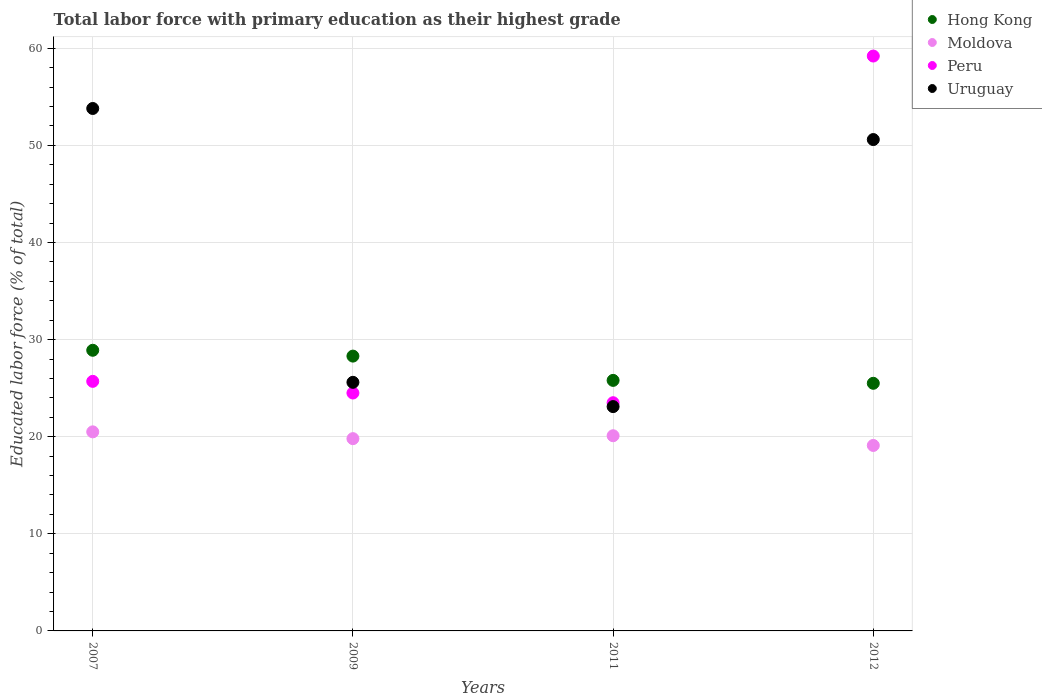How many different coloured dotlines are there?
Your answer should be compact. 4. Across all years, what is the minimum percentage of total labor force with primary education in Peru?
Provide a succinct answer. 23.5. In which year was the percentage of total labor force with primary education in Uruguay maximum?
Your response must be concise. 2007. In which year was the percentage of total labor force with primary education in Uruguay minimum?
Ensure brevity in your answer.  2011. What is the total percentage of total labor force with primary education in Peru in the graph?
Keep it short and to the point. 132.9. What is the difference between the percentage of total labor force with primary education in Uruguay in 2007 and that in 2012?
Give a very brief answer. 3.2. What is the difference between the percentage of total labor force with primary education in Moldova in 2009 and the percentage of total labor force with primary education in Hong Kong in 2007?
Ensure brevity in your answer.  -9.1. What is the average percentage of total labor force with primary education in Hong Kong per year?
Your answer should be very brief. 27.12. In the year 2011, what is the difference between the percentage of total labor force with primary education in Uruguay and percentage of total labor force with primary education in Hong Kong?
Make the answer very short. -2.7. What is the ratio of the percentage of total labor force with primary education in Uruguay in 2007 to that in 2012?
Your response must be concise. 1.06. Is the percentage of total labor force with primary education in Hong Kong in 2007 less than that in 2009?
Offer a very short reply. No. Is the difference between the percentage of total labor force with primary education in Uruguay in 2007 and 2011 greater than the difference between the percentage of total labor force with primary education in Hong Kong in 2007 and 2011?
Your response must be concise. Yes. What is the difference between the highest and the second highest percentage of total labor force with primary education in Hong Kong?
Provide a succinct answer. 0.6. What is the difference between the highest and the lowest percentage of total labor force with primary education in Uruguay?
Provide a short and direct response. 30.7. In how many years, is the percentage of total labor force with primary education in Peru greater than the average percentage of total labor force with primary education in Peru taken over all years?
Ensure brevity in your answer.  1. Is it the case that in every year, the sum of the percentage of total labor force with primary education in Peru and percentage of total labor force with primary education in Moldova  is greater than the sum of percentage of total labor force with primary education in Hong Kong and percentage of total labor force with primary education in Uruguay?
Offer a terse response. No. Is it the case that in every year, the sum of the percentage of total labor force with primary education in Uruguay and percentage of total labor force with primary education in Moldova  is greater than the percentage of total labor force with primary education in Peru?
Your response must be concise. Yes. Does the percentage of total labor force with primary education in Moldova monotonically increase over the years?
Give a very brief answer. No. Is the percentage of total labor force with primary education in Hong Kong strictly less than the percentage of total labor force with primary education in Moldova over the years?
Your answer should be compact. No. How many years are there in the graph?
Offer a very short reply. 4. Does the graph contain grids?
Your answer should be compact. Yes. How many legend labels are there?
Give a very brief answer. 4. How are the legend labels stacked?
Your answer should be compact. Vertical. What is the title of the graph?
Your response must be concise. Total labor force with primary education as their highest grade. Does "Solomon Islands" appear as one of the legend labels in the graph?
Provide a short and direct response. No. What is the label or title of the X-axis?
Give a very brief answer. Years. What is the label or title of the Y-axis?
Offer a terse response. Educated labor force (% of total). What is the Educated labor force (% of total) of Hong Kong in 2007?
Your response must be concise. 28.9. What is the Educated labor force (% of total) in Moldova in 2007?
Offer a very short reply. 20.5. What is the Educated labor force (% of total) in Peru in 2007?
Offer a very short reply. 25.7. What is the Educated labor force (% of total) of Uruguay in 2007?
Provide a short and direct response. 53.8. What is the Educated labor force (% of total) of Hong Kong in 2009?
Your response must be concise. 28.3. What is the Educated labor force (% of total) of Moldova in 2009?
Offer a very short reply. 19.8. What is the Educated labor force (% of total) in Uruguay in 2009?
Your response must be concise. 25.6. What is the Educated labor force (% of total) in Hong Kong in 2011?
Provide a succinct answer. 25.8. What is the Educated labor force (% of total) of Moldova in 2011?
Make the answer very short. 20.1. What is the Educated labor force (% of total) in Uruguay in 2011?
Your answer should be very brief. 23.1. What is the Educated labor force (% of total) in Hong Kong in 2012?
Offer a terse response. 25.5. What is the Educated labor force (% of total) in Moldova in 2012?
Make the answer very short. 19.1. What is the Educated labor force (% of total) of Peru in 2012?
Offer a very short reply. 59.2. What is the Educated labor force (% of total) of Uruguay in 2012?
Provide a short and direct response. 50.6. Across all years, what is the maximum Educated labor force (% of total) of Hong Kong?
Give a very brief answer. 28.9. Across all years, what is the maximum Educated labor force (% of total) of Peru?
Your answer should be compact. 59.2. Across all years, what is the maximum Educated labor force (% of total) of Uruguay?
Offer a very short reply. 53.8. Across all years, what is the minimum Educated labor force (% of total) in Moldova?
Give a very brief answer. 19.1. Across all years, what is the minimum Educated labor force (% of total) in Uruguay?
Make the answer very short. 23.1. What is the total Educated labor force (% of total) of Hong Kong in the graph?
Your response must be concise. 108.5. What is the total Educated labor force (% of total) of Moldova in the graph?
Keep it short and to the point. 79.5. What is the total Educated labor force (% of total) in Peru in the graph?
Your response must be concise. 132.9. What is the total Educated labor force (% of total) in Uruguay in the graph?
Offer a terse response. 153.1. What is the difference between the Educated labor force (% of total) of Hong Kong in 2007 and that in 2009?
Your answer should be very brief. 0.6. What is the difference between the Educated labor force (% of total) of Moldova in 2007 and that in 2009?
Your answer should be compact. 0.7. What is the difference between the Educated labor force (% of total) of Peru in 2007 and that in 2009?
Give a very brief answer. 1.2. What is the difference between the Educated labor force (% of total) in Uruguay in 2007 and that in 2009?
Give a very brief answer. 28.2. What is the difference between the Educated labor force (% of total) in Hong Kong in 2007 and that in 2011?
Give a very brief answer. 3.1. What is the difference between the Educated labor force (% of total) in Moldova in 2007 and that in 2011?
Provide a succinct answer. 0.4. What is the difference between the Educated labor force (% of total) in Uruguay in 2007 and that in 2011?
Your answer should be very brief. 30.7. What is the difference between the Educated labor force (% of total) of Hong Kong in 2007 and that in 2012?
Your answer should be compact. 3.4. What is the difference between the Educated labor force (% of total) in Peru in 2007 and that in 2012?
Give a very brief answer. -33.5. What is the difference between the Educated labor force (% of total) in Uruguay in 2007 and that in 2012?
Your answer should be very brief. 3.2. What is the difference between the Educated labor force (% of total) of Peru in 2009 and that in 2011?
Make the answer very short. 1. What is the difference between the Educated labor force (% of total) in Peru in 2009 and that in 2012?
Give a very brief answer. -34.7. What is the difference between the Educated labor force (% of total) in Hong Kong in 2011 and that in 2012?
Offer a very short reply. 0.3. What is the difference between the Educated labor force (% of total) in Peru in 2011 and that in 2012?
Offer a very short reply. -35.7. What is the difference between the Educated labor force (% of total) in Uruguay in 2011 and that in 2012?
Your answer should be compact. -27.5. What is the difference between the Educated labor force (% of total) of Hong Kong in 2007 and the Educated labor force (% of total) of Moldova in 2009?
Ensure brevity in your answer.  9.1. What is the difference between the Educated labor force (% of total) in Hong Kong in 2007 and the Educated labor force (% of total) in Peru in 2009?
Provide a succinct answer. 4.4. What is the difference between the Educated labor force (% of total) of Moldova in 2007 and the Educated labor force (% of total) of Peru in 2009?
Your answer should be very brief. -4. What is the difference between the Educated labor force (% of total) of Moldova in 2007 and the Educated labor force (% of total) of Uruguay in 2009?
Ensure brevity in your answer.  -5.1. What is the difference between the Educated labor force (% of total) of Peru in 2007 and the Educated labor force (% of total) of Uruguay in 2009?
Make the answer very short. 0.1. What is the difference between the Educated labor force (% of total) in Hong Kong in 2007 and the Educated labor force (% of total) in Moldova in 2011?
Your answer should be compact. 8.8. What is the difference between the Educated labor force (% of total) of Moldova in 2007 and the Educated labor force (% of total) of Peru in 2011?
Your answer should be compact. -3. What is the difference between the Educated labor force (% of total) of Peru in 2007 and the Educated labor force (% of total) of Uruguay in 2011?
Offer a very short reply. 2.6. What is the difference between the Educated labor force (% of total) of Hong Kong in 2007 and the Educated labor force (% of total) of Peru in 2012?
Your answer should be very brief. -30.3. What is the difference between the Educated labor force (% of total) in Hong Kong in 2007 and the Educated labor force (% of total) in Uruguay in 2012?
Offer a terse response. -21.7. What is the difference between the Educated labor force (% of total) of Moldova in 2007 and the Educated labor force (% of total) of Peru in 2012?
Your response must be concise. -38.7. What is the difference between the Educated labor force (% of total) in Moldova in 2007 and the Educated labor force (% of total) in Uruguay in 2012?
Provide a short and direct response. -30.1. What is the difference between the Educated labor force (% of total) of Peru in 2007 and the Educated labor force (% of total) of Uruguay in 2012?
Offer a very short reply. -24.9. What is the difference between the Educated labor force (% of total) in Hong Kong in 2009 and the Educated labor force (% of total) in Uruguay in 2011?
Offer a terse response. 5.2. What is the difference between the Educated labor force (% of total) of Moldova in 2009 and the Educated labor force (% of total) of Peru in 2011?
Provide a succinct answer. -3.7. What is the difference between the Educated labor force (% of total) of Moldova in 2009 and the Educated labor force (% of total) of Uruguay in 2011?
Your response must be concise. -3.3. What is the difference between the Educated labor force (% of total) in Peru in 2009 and the Educated labor force (% of total) in Uruguay in 2011?
Your answer should be compact. 1.4. What is the difference between the Educated labor force (% of total) in Hong Kong in 2009 and the Educated labor force (% of total) in Peru in 2012?
Keep it short and to the point. -30.9. What is the difference between the Educated labor force (% of total) in Hong Kong in 2009 and the Educated labor force (% of total) in Uruguay in 2012?
Offer a terse response. -22.3. What is the difference between the Educated labor force (% of total) in Moldova in 2009 and the Educated labor force (% of total) in Peru in 2012?
Offer a terse response. -39.4. What is the difference between the Educated labor force (% of total) of Moldova in 2009 and the Educated labor force (% of total) of Uruguay in 2012?
Your answer should be compact. -30.8. What is the difference between the Educated labor force (% of total) of Peru in 2009 and the Educated labor force (% of total) of Uruguay in 2012?
Your response must be concise. -26.1. What is the difference between the Educated labor force (% of total) in Hong Kong in 2011 and the Educated labor force (% of total) in Moldova in 2012?
Your response must be concise. 6.7. What is the difference between the Educated labor force (% of total) in Hong Kong in 2011 and the Educated labor force (% of total) in Peru in 2012?
Offer a very short reply. -33.4. What is the difference between the Educated labor force (% of total) of Hong Kong in 2011 and the Educated labor force (% of total) of Uruguay in 2012?
Your answer should be compact. -24.8. What is the difference between the Educated labor force (% of total) in Moldova in 2011 and the Educated labor force (% of total) in Peru in 2012?
Your answer should be compact. -39.1. What is the difference between the Educated labor force (% of total) of Moldova in 2011 and the Educated labor force (% of total) of Uruguay in 2012?
Provide a succinct answer. -30.5. What is the difference between the Educated labor force (% of total) of Peru in 2011 and the Educated labor force (% of total) of Uruguay in 2012?
Your answer should be compact. -27.1. What is the average Educated labor force (% of total) of Hong Kong per year?
Make the answer very short. 27.12. What is the average Educated labor force (% of total) in Moldova per year?
Make the answer very short. 19.88. What is the average Educated labor force (% of total) in Peru per year?
Provide a succinct answer. 33.23. What is the average Educated labor force (% of total) of Uruguay per year?
Make the answer very short. 38.27. In the year 2007, what is the difference between the Educated labor force (% of total) in Hong Kong and Educated labor force (% of total) in Uruguay?
Offer a terse response. -24.9. In the year 2007, what is the difference between the Educated labor force (% of total) in Moldova and Educated labor force (% of total) in Uruguay?
Ensure brevity in your answer.  -33.3. In the year 2007, what is the difference between the Educated labor force (% of total) of Peru and Educated labor force (% of total) of Uruguay?
Offer a terse response. -28.1. In the year 2009, what is the difference between the Educated labor force (% of total) in Hong Kong and Educated labor force (% of total) in Moldova?
Ensure brevity in your answer.  8.5. In the year 2009, what is the difference between the Educated labor force (% of total) in Moldova and Educated labor force (% of total) in Uruguay?
Your response must be concise. -5.8. In the year 2011, what is the difference between the Educated labor force (% of total) in Hong Kong and Educated labor force (% of total) in Uruguay?
Offer a terse response. 2.7. In the year 2012, what is the difference between the Educated labor force (% of total) of Hong Kong and Educated labor force (% of total) of Peru?
Give a very brief answer. -33.7. In the year 2012, what is the difference between the Educated labor force (% of total) of Hong Kong and Educated labor force (% of total) of Uruguay?
Your answer should be very brief. -25.1. In the year 2012, what is the difference between the Educated labor force (% of total) of Moldova and Educated labor force (% of total) of Peru?
Offer a very short reply. -40.1. In the year 2012, what is the difference between the Educated labor force (% of total) of Moldova and Educated labor force (% of total) of Uruguay?
Give a very brief answer. -31.5. In the year 2012, what is the difference between the Educated labor force (% of total) in Peru and Educated labor force (% of total) in Uruguay?
Make the answer very short. 8.6. What is the ratio of the Educated labor force (% of total) in Hong Kong in 2007 to that in 2009?
Give a very brief answer. 1.02. What is the ratio of the Educated labor force (% of total) in Moldova in 2007 to that in 2009?
Make the answer very short. 1.04. What is the ratio of the Educated labor force (% of total) in Peru in 2007 to that in 2009?
Your answer should be very brief. 1.05. What is the ratio of the Educated labor force (% of total) in Uruguay in 2007 to that in 2009?
Your response must be concise. 2.1. What is the ratio of the Educated labor force (% of total) of Hong Kong in 2007 to that in 2011?
Keep it short and to the point. 1.12. What is the ratio of the Educated labor force (% of total) in Moldova in 2007 to that in 2011?
Provide a succinct answer. 1.02. What is the ratio of the Educated labor force (% of total) in Peru in 2007 to that in 2011?
Your answer should be compact. 1.09. What is the ratio of the Educated labor force (% of total) of Uruguay in 2007 to that in 2011?
Provide a succinct answer. 2.33. What is the ratio of the Educated labor force (% of total) in Hong Kong in 2007 to that in 2012?
Your response must be concise. 1.13. What is the ratio of the Educated labor force (% of total) of Moldova in 2007 to that in 2012?
Provide a short and direct response. 1.07. What is the ratio of the Educated labor force (% of total) in Peru in 2007 to that in 2012?
Provide a succinct answer. 0.43. What is the ratio of the Educated labor force (% of total) in Uruguay in 2007 to that in 2012?
Make the answer very short. 1.06. What is the ratio of the Educated labor force (% of total) in Hong Kong in 2009 to that in 2011?
Keep it short and to the point. 1.1. What is the ratio of the Educated labor force (% of total) in Moldova in 2009 to that in 2011?
Provide a succinct answer. 0.99. What is the ratio of the Educated labor force (% of total) of Peru in 2009 to that in 2011?
Give a very brief answer. 1.04. What is the ratio of the Educated labor force (% of total) of Uruguay in 2009 to that in 2011?
Keep it short and to the point. 1.11. What is the ratio of the Educated labor force (% of total) in Hong Kong in 2009 to that in 2012?
Ensure brevity in your answer.  1.11. What is the ratio of the Educated labor force (% of total) of Moldova in 2009 to that in 2012?
Your response must be concise. 1.04. What is the ratio of the Educated labor force (% of total) of Peru in 2009 to that in 2012?
Provide a succinct answer. 0.41. What is the ratio of the Educated labor force (% of total) of Uruguay in 2009 to that in 2012?
Your response must be concise. 0.51. What is the ratio of the Educated labor force (% of total) in Hong Kong in 2011 to that in 2012?
Offer a terse response. 1.01. What is the ratio of the Educated labor force (% of total) of Moldova in 2011 to that in 2012?
Provide a succinct answer. 1.05. What is the ratio of the Educated labor force (% of total) of Peru in 2011 to that in 2012?
Your answer should be compact. 0.4. What is the ratio of the Educated labor force (% of total) of Uruguay in 2011 to that in 2012?
Provide a short and direct response. 0.46. What is the difference between the highest and the second highest Educated labor force (% of total) of Hong Kong?
Ensure brevity in your answer.  0.6. What is the difference between the highest and the second highest Educated labor force (% of total) in Peru?
Offer a very short reply. 33.5. What is the difference between the highest and the lowest Educated labor force (% of total) of Peru?
Your answer should be very brief. 35.7. What is the difference between the highest and the lowest Educated labor force (% of total) of Uruguay?
Offer a terse response. 30.7. 